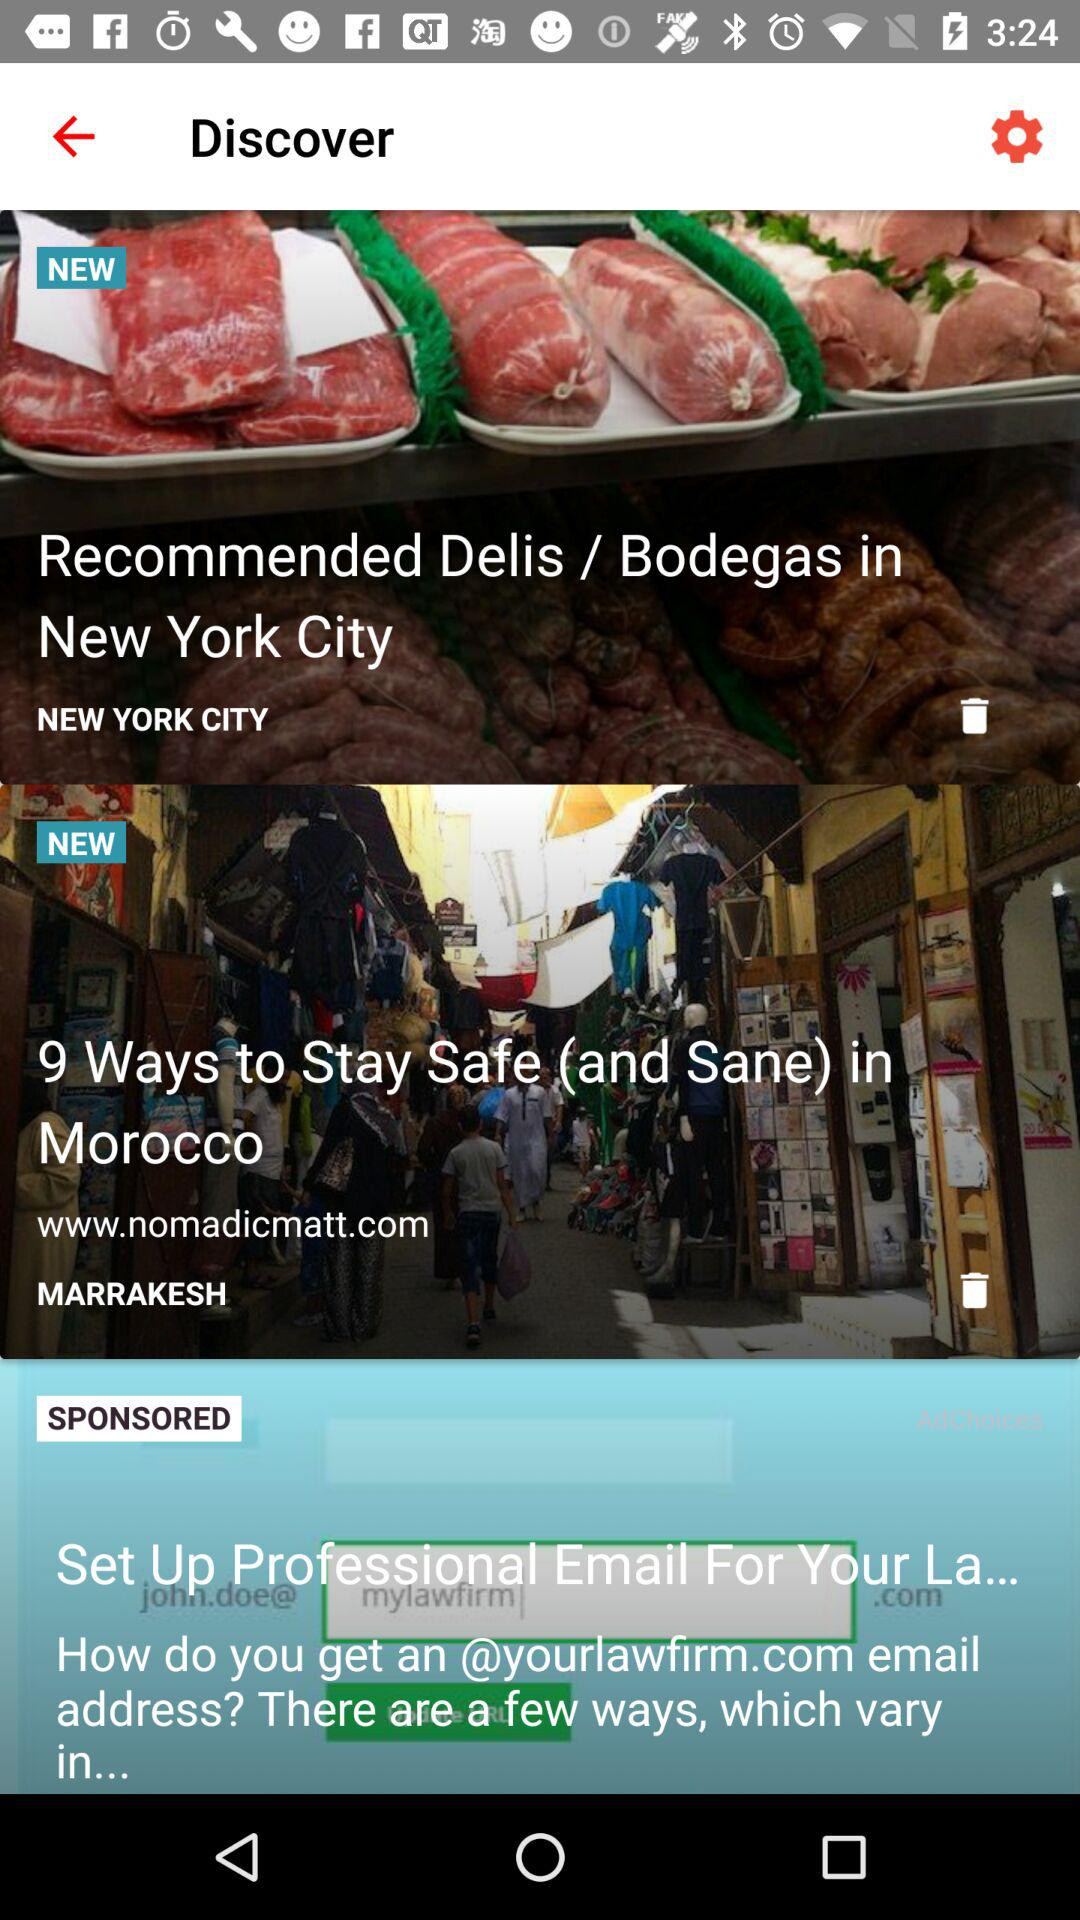How many ways are there to stay safe in Morocco? There are 9 ways to stay safe in Morocco. 